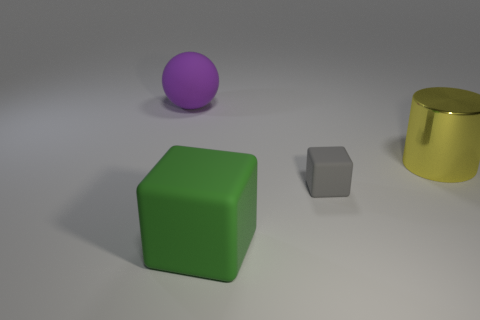Add 2 big red metallic cylinders. How many objects exist? 6 Subtract all cylinders. How many objects are left? 3 Subtract all small matte things. Subtract all tiny yellow cylinders. How many objects are left? 3 Add 2 purple matte spheres. How many purple matte spheres are left? 3 Add 4 small brown metallic blocks. How many small brown metallic blocks exist? 4 Subtract 0 blue balls. How many objects are left? 4 